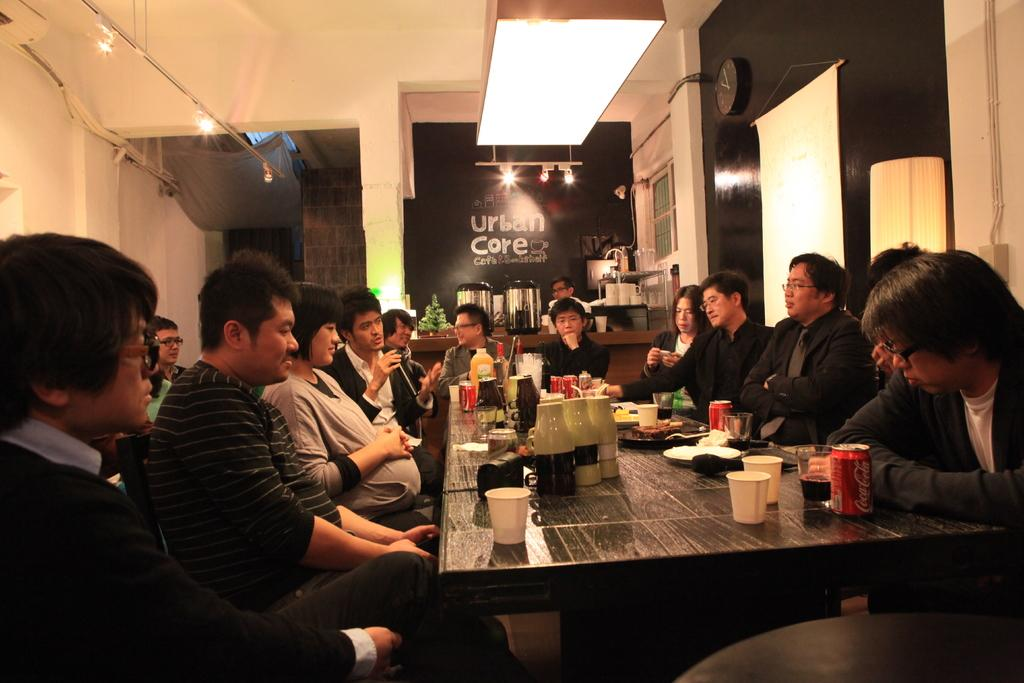<image>
Give a short and clear explanation of the subsequent image. the words urban core are on a black board 